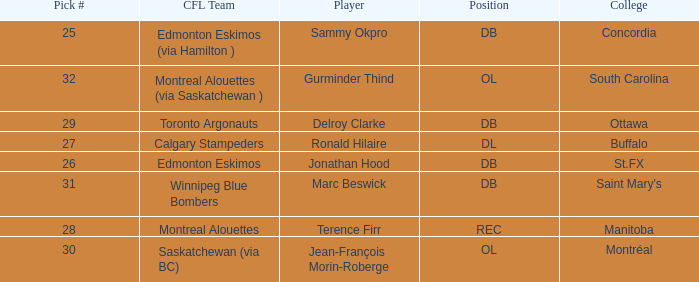Which Pick # has a College of concordia? 25.0. 